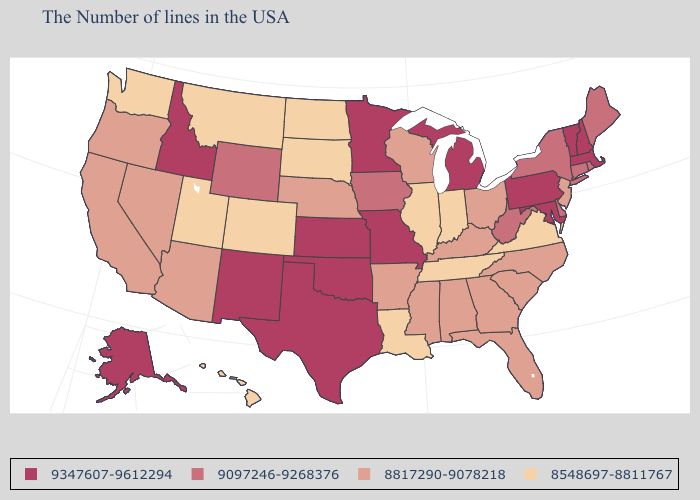What is the value of Tennessee?
Write a very short answer. 8548697-8811767. Name the states that have a value in the range 8817290-9078218?
Concise answer only. New Jersey, North Carolina, South Carolina, Ohio, Florida, Georgia, Kentucky, Alabama, Wisconsin, Mississippi, Arkansas, Nebraska, Arizona, Nevada, California, Oregon. Does Hawaii have the lowest value in the USA?
Keep it brief. Yes. What is the value of Wisconsin?
Concise answer only. 8817290-9078218. Name the states that have a value in the range 8817290-9078218?
Be succinct. New Jersey, North Carolina, South Carolina, Ohio, Florida, Georgia, Kentucky, Alabama, Wisconsin, Mississippi, Arkansas, Nebraska, Arizona, Nevada, California, Oregon. Does Delaware have a lower value than North Carolina?
Give a very brief answer. No. What is the value of Kentucky?
Give a very brief answer. 8817290-9078218. What is the value of Georgia?
Short answer required. 8817290-9078218. Name the states that have a value in the range 8548697-8811767?
Keep it brief. Virginia, Indiana, Tennessee, Illinois, Louisiana, South Dakota, North Dakota, Colorado, Utah, Montana, Washington, Hawaii. Which states have the lowest value in the USA?
Give a very brief answer. Virginia, Indiana, Tennessee, Illinois, Louisiana, South Dakota, North Dakota, Colorado, Utah, Montana, Washington, Hawaii. What is the value of Kentucky?
Answer briefly. 8817290-9078218. Does the map have missing data?
Answer briefly. No. What is the value of Minnesota?
Concise answer only. 9347607-9612294. What is the lowest value in the MidWest?
Short answer required. 8548697-8811767. What is the value of Nebraska?
Keep it brief. 8817290-9078218. 